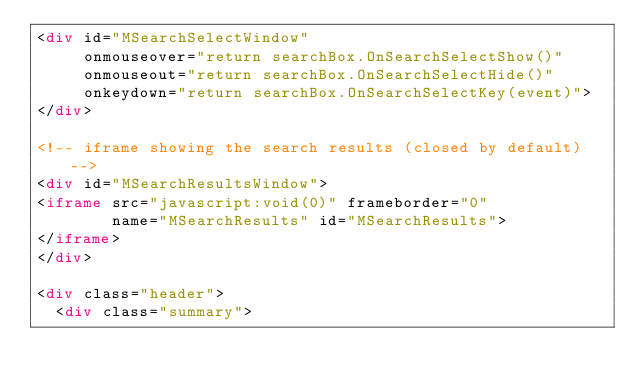Convert code to text. <code><loc_0><loc_0><loc_500><loc_500><_HTML_><div id="MSearchSelectWindow"
     onmouseover="return searchBox.OnSearchSelectShow()"
     onmouseout="return searchBox.OnSearchSelectHide()"
     onkeydown="return searchBox.OnSearchSelectKey(event)">
</div>

<!-- iframe showing the search results (closed by default) -->
<div id="MSearchResultsWindow">
<iframe src="javascript:void(0)" frameborder="0" 
        name="MSearchResults" id="MSearchResults">
</iframe>
</div>

<div class="header">
  <div class="summary"></code> 